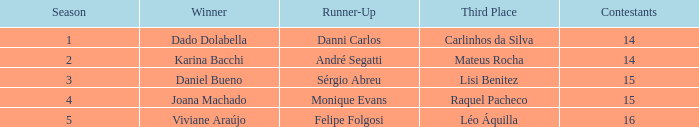Who finished in third place when the winner was Karina Bacchi?  Mateus Rocha. 